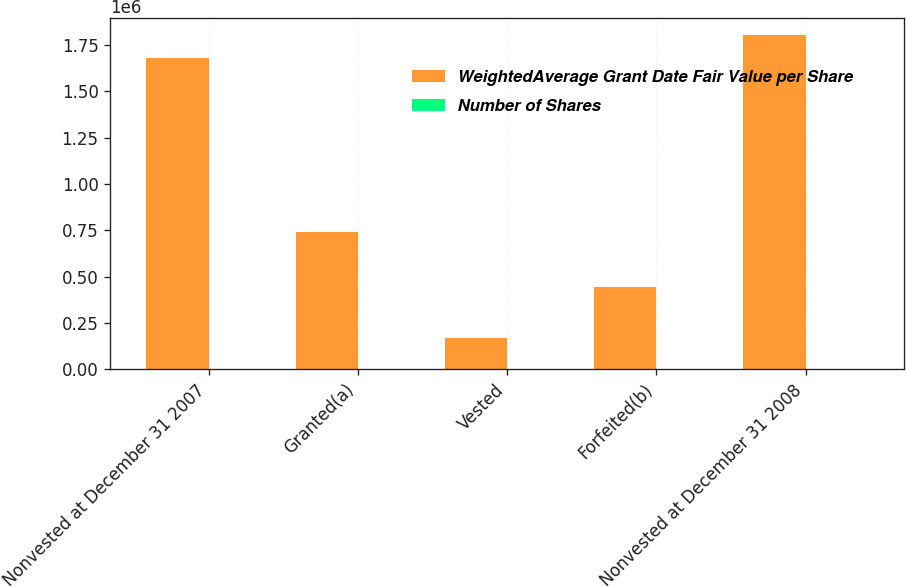Convert chart. <chart><loc_0><loc_0><loc_500><loc_500><stacked_bar_chart><ecel><fcel>Nonvested at December 31 2007<fcel>Granted(a)<fcel>Vested<fcel>Forfeited(b)<fcel>Nonvested at December 31 2008<nl><fcel>WeightedAverage Grant Date Fair Value per Share<fcel>1.68145e+06<fcel>739350<fcel>171004<fcel>445500<fcel>1.8043e+06<nl><fcel>Number of Shares<fcel>13.52<fcel>10.38<fcel>13.67<fcel>15.34<fcel>12.1<nl></chart> 